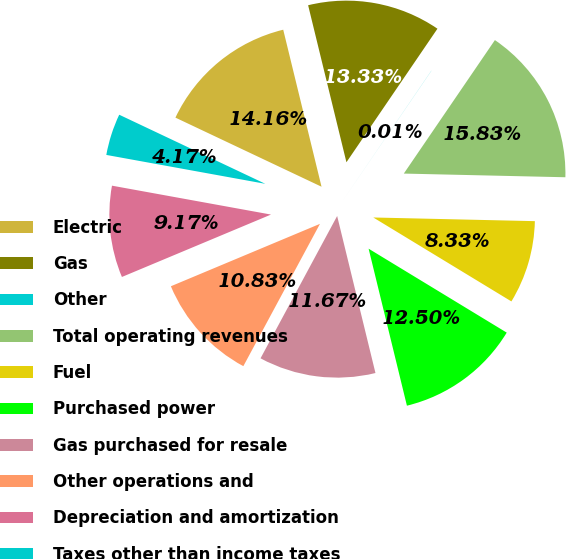Convert chart. <chart><loc_0><loc_0><loc_500><loc_500><pie_chart><fcel>Electric<fcel>Gas<fcel>Other<fcel>Total operating revenues<fcel>Fuel<fcel>Purchased power<fcel>Gas purchased for resale<fcel>Other operations and<fcel>Depreciation and amortization<fcel>Taxes other than income taxes<nl><fcel>14.16%<fcel>13.33%<fcel>0.01%<fcel>15.83%<fcel>8.33%<fcel>12.5%<fcel>11.67%<fcel>10.83%<fcel>9.17%<fcel>4.17%<nl></chart> 